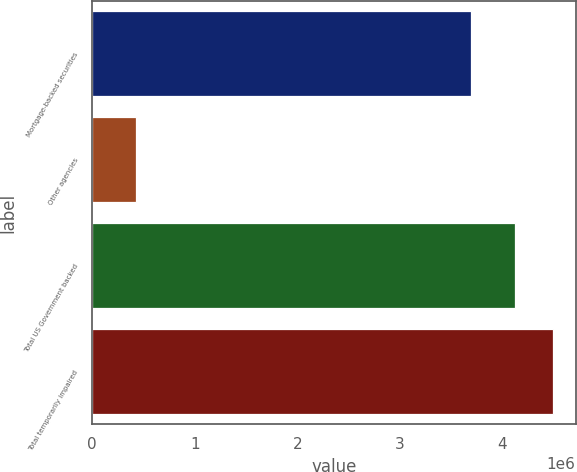Convert chart to OTSL. <chart><loc_0><loc_0><loc_500><loc_500><bar_chart><fcel>Mortgage-backed securities<fcel>Other agencies<fcel>Total US Government backed<fcel>Total temporarily impaired<nl><fcel>3.69289e+06<fcel>425410<fcel>4.1183e+06<fcel>4.48759e+06<nl></chart> 